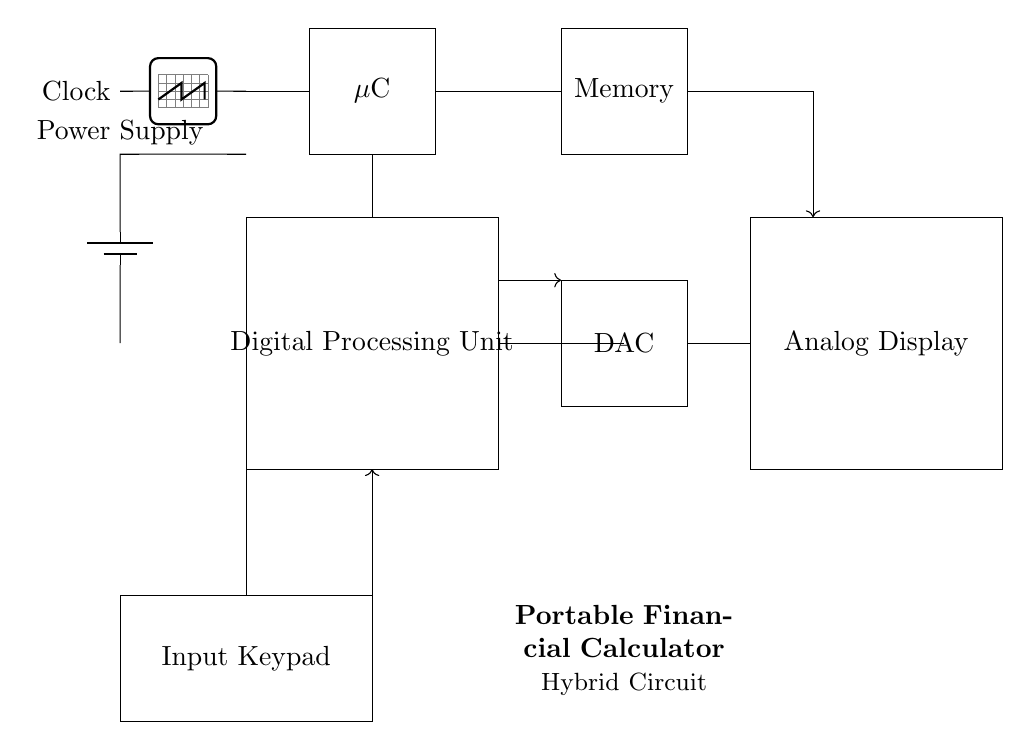What is the main function of the Digital Processing Unit? The Digital Processing Unit processes the input data using algorithms to perform financial calculations.
Answer: Financial calculations What component connects the Input Keypad to the Digital Processing Unit? The connection is indicated by a vertical line from the Input Keypad that goes directly to the Digital Processing Unit.
Answer: Input connection How many main units are shown in the circuit? There are three main units: the Digital Processing Unit, Analog Display, and Power Supply.
Answer: Three What does DAC stand for in this circuit? DAC stands for Digital to Analog Converter, which translates digital signals from the processing unit into analog signals for the display.
Answer: Digital to Analog Converter Which component provides timing signals for the microcontroller? The Clock component provides the timing signals necessary for the microcontroller to function correctly.
Answer: Clock How does data flow from the Memory to the Analog Display in this design? Data flows from the Memory to the Digital to Analog Converter first, then to the Analog Display. The connections indicate this sequence.
Answer: Through DAC What is the component indicated for user input in this circuit? The component for user input is the Input Keypad, which allows users to enter data and commands into the system.
Answer: Input Keypad 